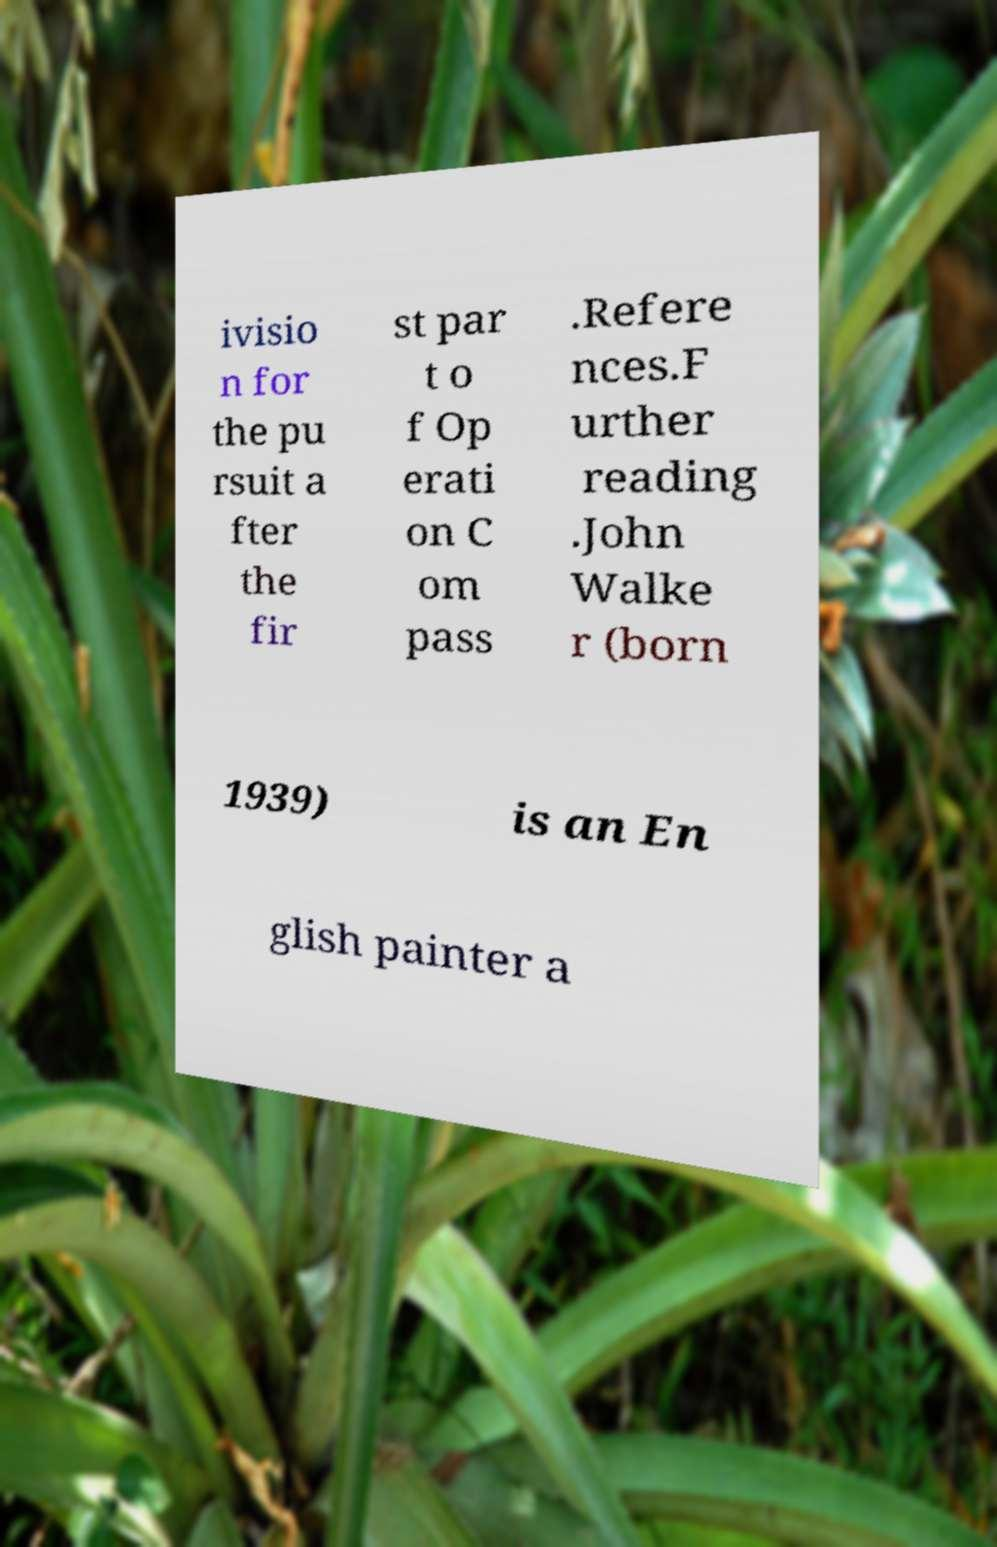Can you accurately transcribe the text from the provided image for me? ivisio n for the pu rsuit a fter the fir st par t o f Op erati on C om pass .Refere nces.F urther reading .John Walke r (born 1939) is an En glish painter a 